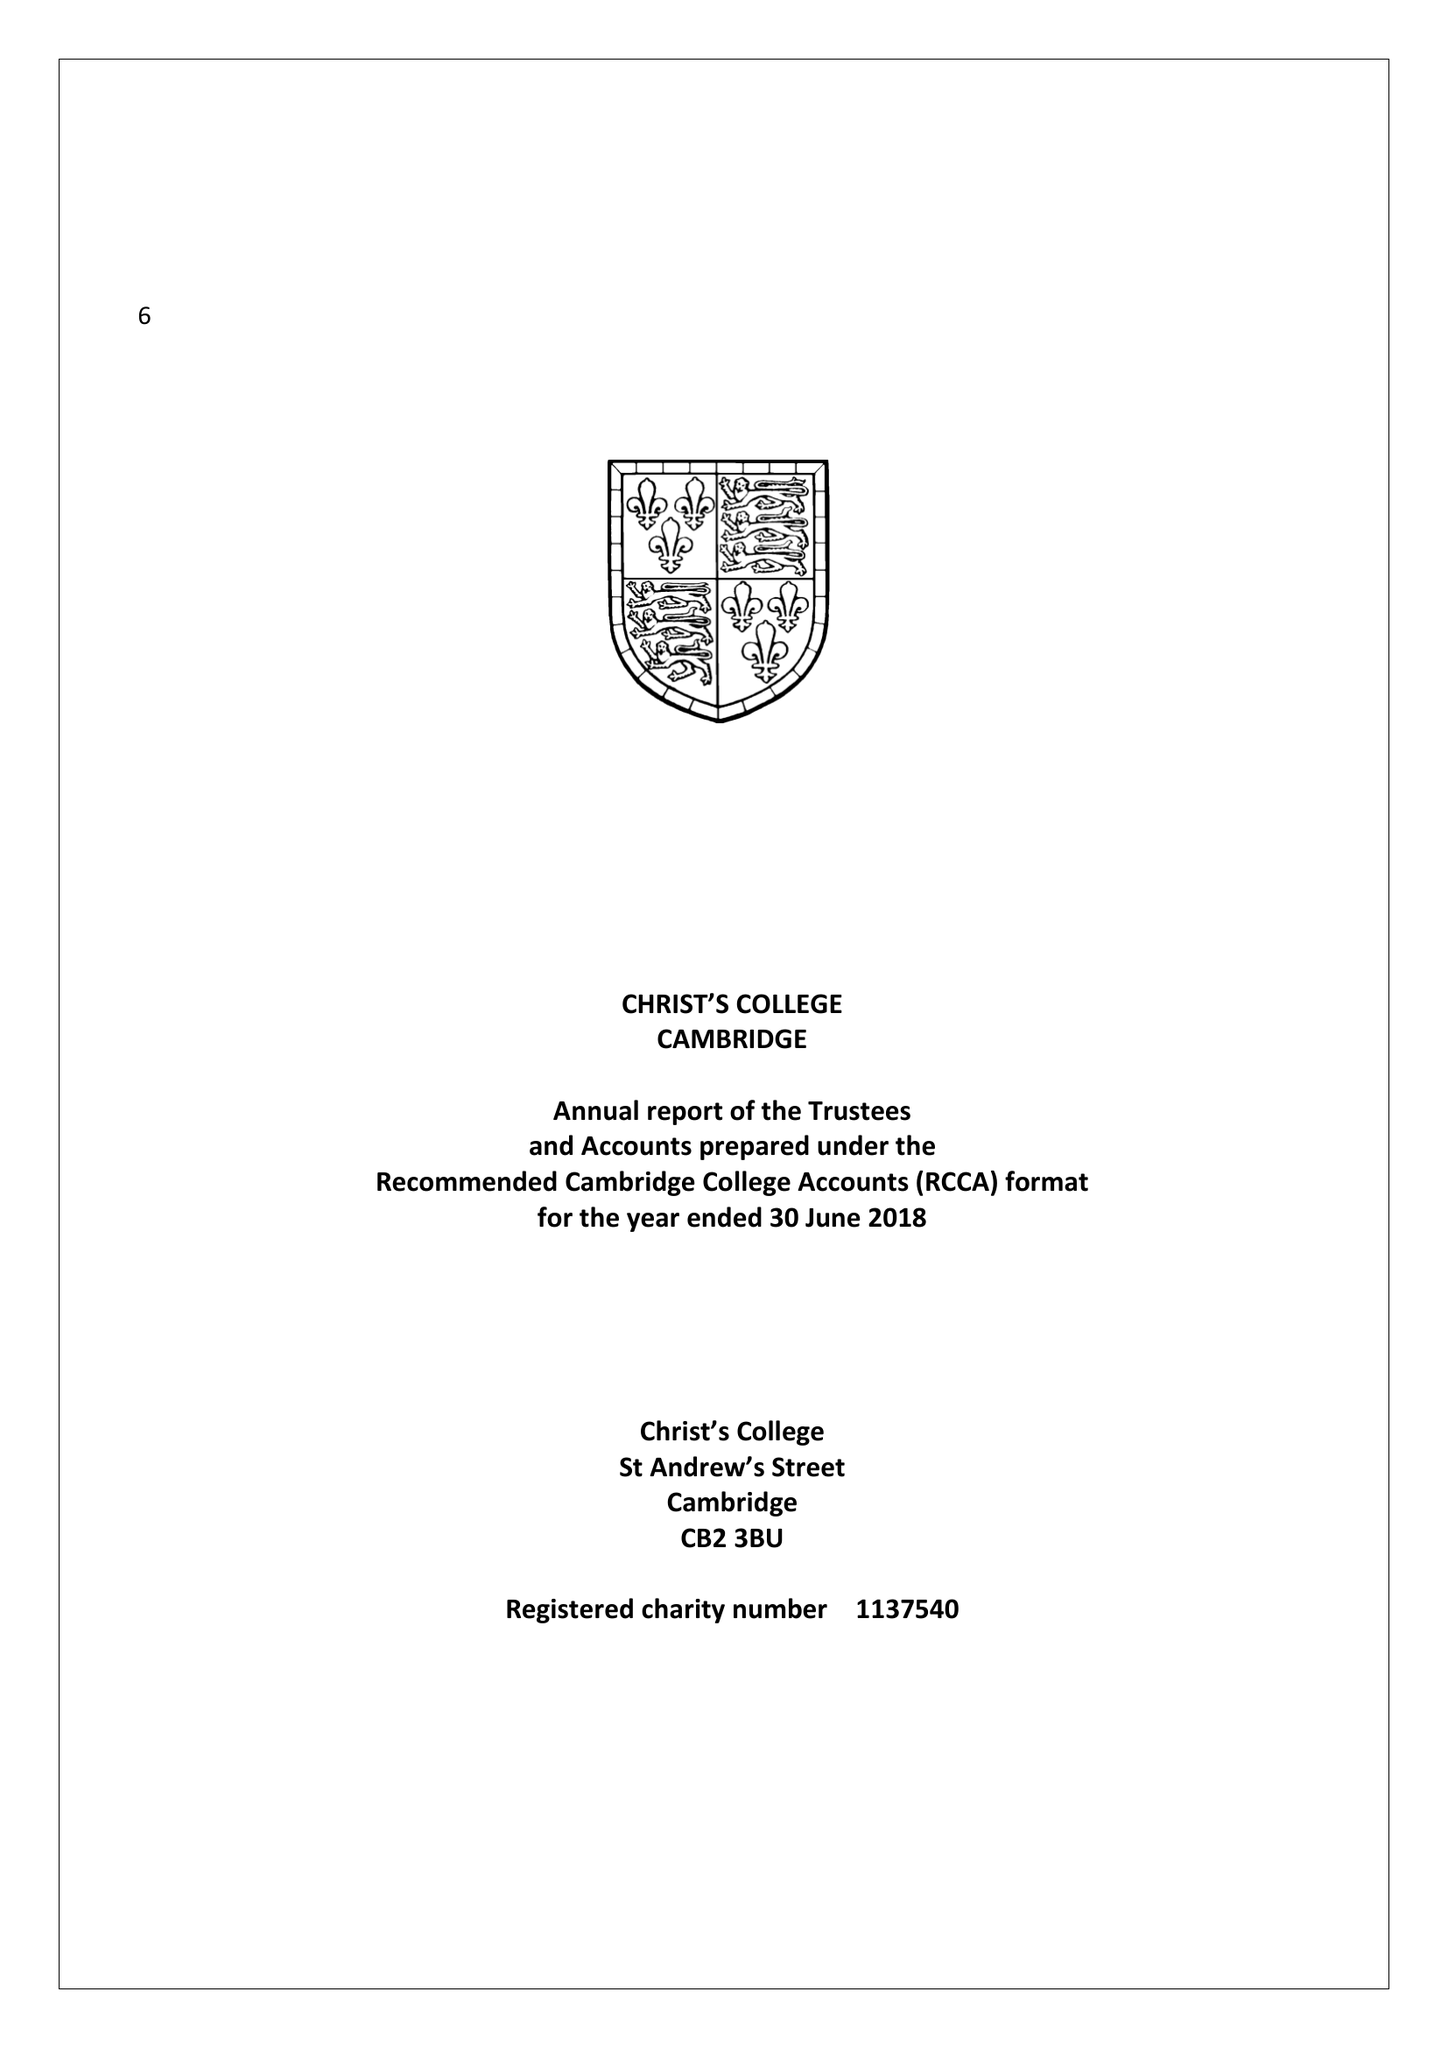What is the value for the charity_number?
Answer the question using a single word or phrase. 1137540 